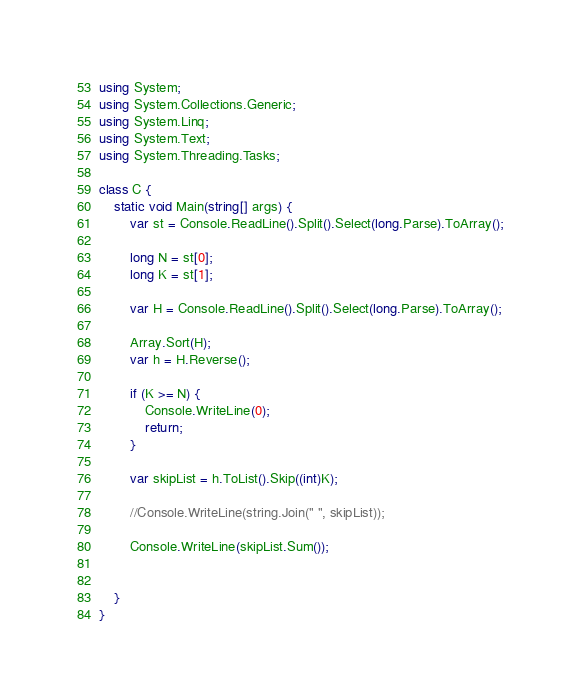Convert code to text. <code><loc_0><loc_0><loc_500><loc_500><_C#_>using System;
using System.Collections.Generic;
using System.Linq;
using System.Text;
using System.Threading.Tasks;

class C {
    static void Main(string[] args) {
        var st = Console.ReadLine().Split().Select(long.Parse).ToArray();

        long N = st[0];
        long K = st[1];

        var H = Console.ReadLine().Split().Select(long.Parse).ToArray();

        Array.Sort(H);
        var h = H.Reverse();

        if (K >= N) {
            Console.WriteLine(0);
            return;
        }

        var skipList = h.ToList().Skip((int)K);

        //Console.WriteLine(string.Join(" ", skipList));

        Console.WriteLine(skipList.Sum());


    }
}</code> 